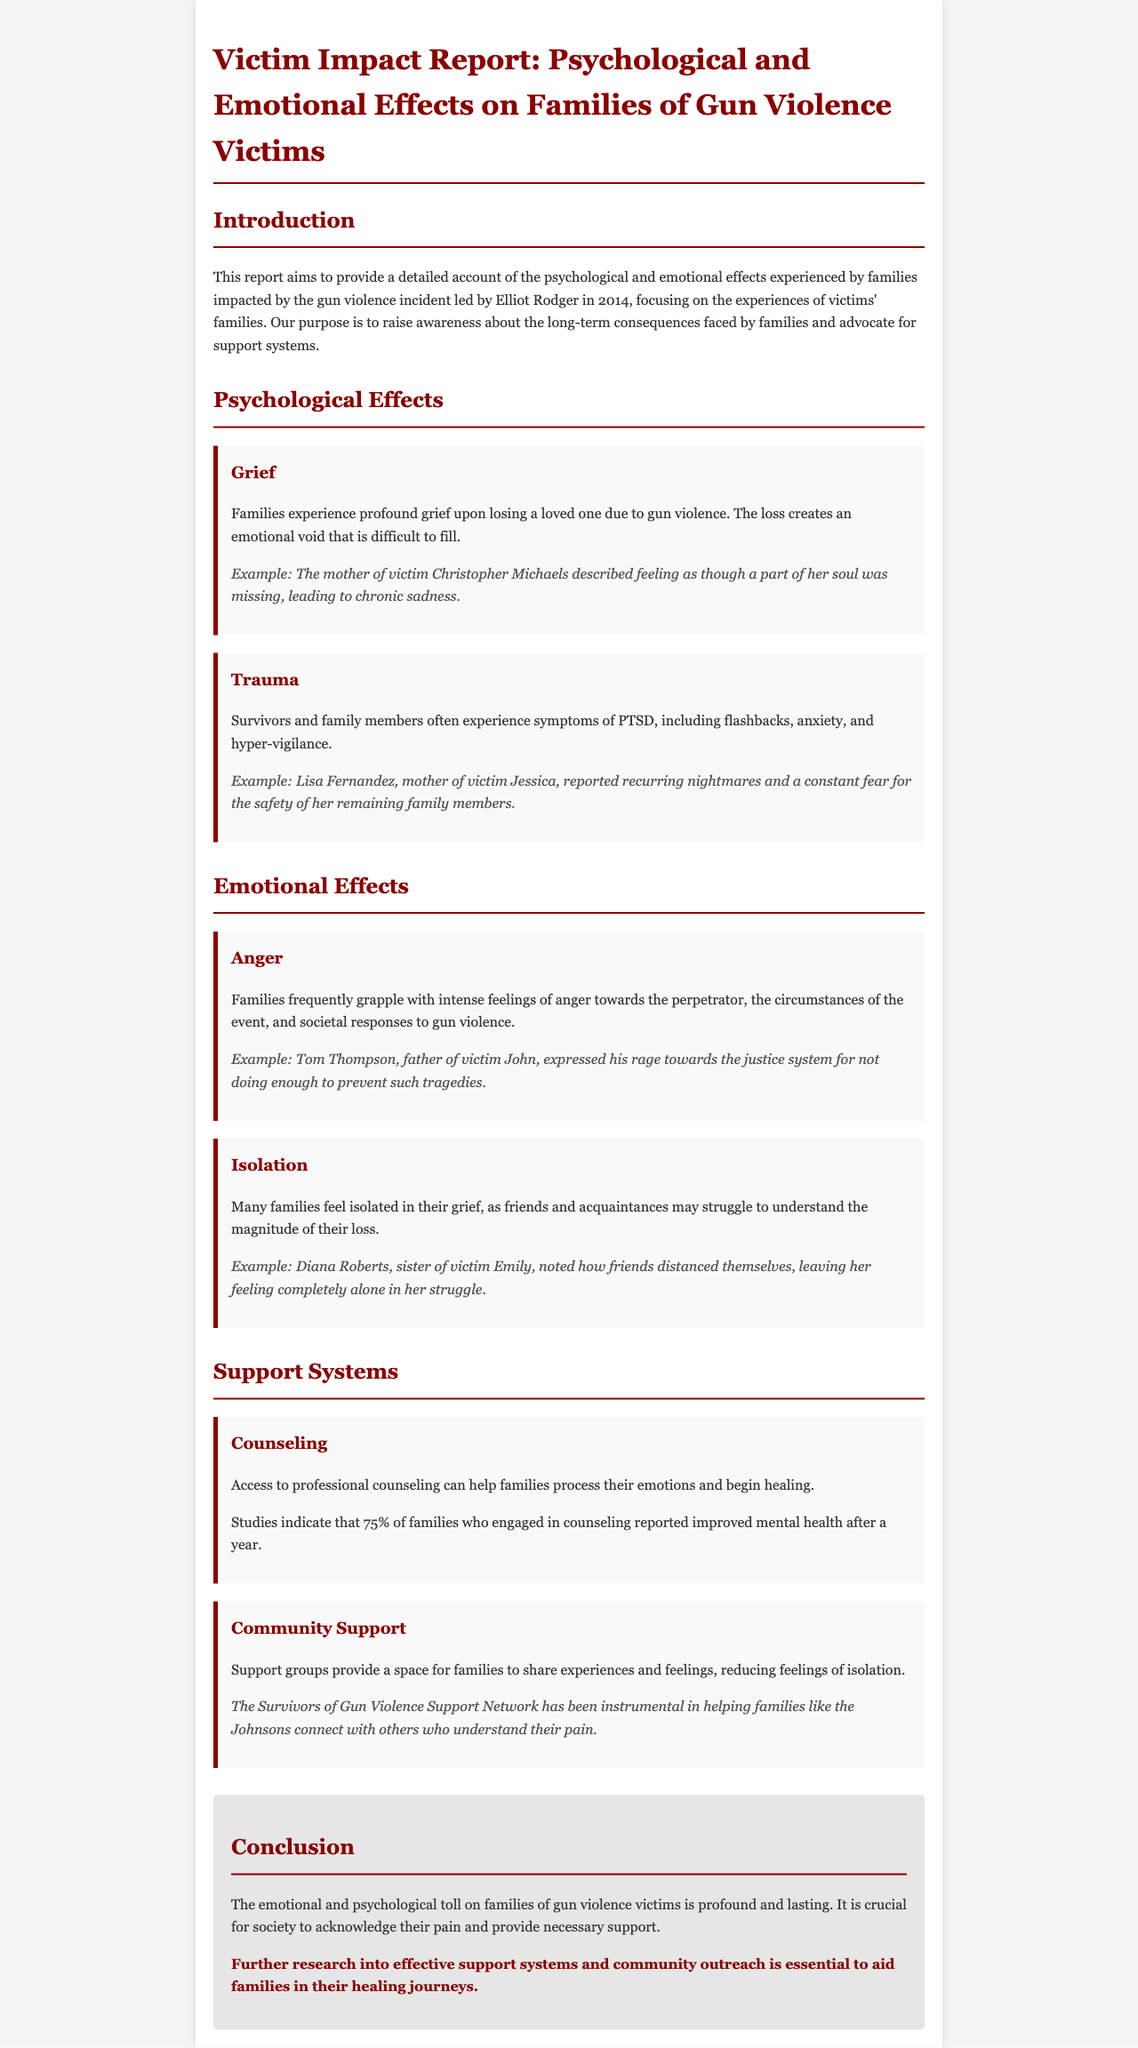what is the main focus of the report? The main focus of the report is to provide a detailed account of the psychological and emotional effects experienced by families impacted by gun violence.
Answer: psychological and emotional effects who was the perpetrator of the gun violence incident in 2014? The perpetrator of the gun violence incident in 2014 was Elliot Rodger.
Answer: Elliot Rodger what percentage of families reported improved mental health after engaging in counseling? The report states that 75% of families who engaged in counseling reported improved mental health after a year.
Answer: 75% name one emotional effect experienced by families of gun violence victims. One emotional effect experienced by families is anger.
Answer: anger what is one example of community support mentioned in the report? The report mentions that the Survivors of Gun Violence Support Network provides a space for families to share experiences and feelings.
Answer: Survivors of Gun Violence Support Network what is the emotional state described by the mother of victim Christopher Michaels? The mother of victim Christopher Michaels described her emotional state as chronic sadness.
Answer: chronic sadness how does the report suggest families often feel in their grief? The report suggests that many families feel isolated in their grief.
Answer: isolated what type of therapy is mentioned as beneficial for families? The report mentions counseling as a beneficial type of therapy for families.
Answer: counseling 